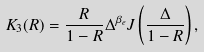Convert formula to latex. <formula><loc_0><loc_0><loc_500><loc_500>K _ { 3 } ( R ) = \frac { R } { 1 - R } \Delta ^ { \beta _ { e } } J \left ( \frac { \Delta } { 1 - R } \right ) ,</formula> 